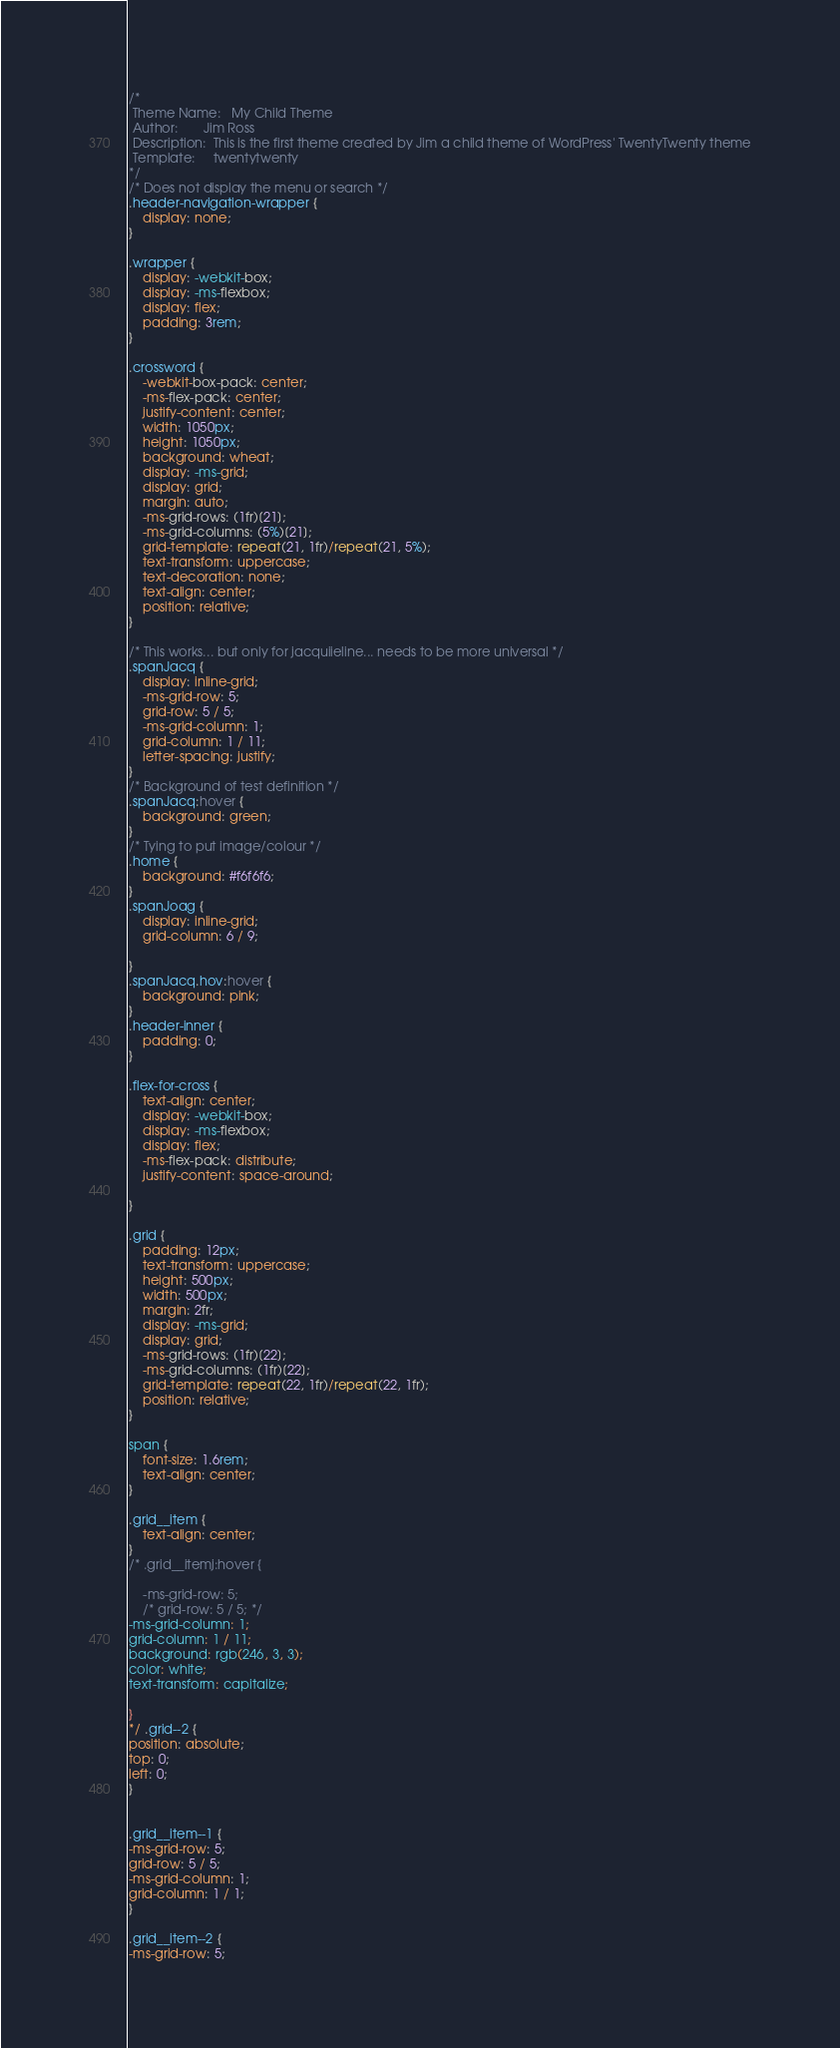Convert code to text. <code><loc_0><loc_0><loc_500><loc_500><_CSS_>/*
 Theme Name:   My Child Theme
 Author:       Jim Ross
 Description:  This is the first theme created by Jim a child theme of WordPress' TwentyTwenty theme
 Template:     twentytwenty
*/
/* Does not display the menu or search */
.header-navigation-wrapper {
    display: none;
}

.wrapper {
    display: -webkit-box;
    display: -ms-flexbox;
    display: flex;
    padding: 3rem;
}

.crossword {
    -webkit-box-pack: center;
    -ms-flex-pack: center;
    justify-content: center;
    width: 1050px;
    height: 1050px;
    background: wheat;
    display: -ms-grid;
    display: grid;
    margin: auto;
    -ms-grid-rows: (1fr)[21];
    -ms-grid-columns: (5%)[21];
    grid-template: repeat(21, 1fr)/repeat(21, 5%);
    text-transform: uppercase;
    text-decoration: none;
    text-align: center;
    position: relative;
}

/* This works... but only for jacquiieline... needs to be more universal */
.spanJacq {
    display: inline-grid;
    -ms-grid-row: 5;
    grid-row: 5 / 5;
    -ms-grid-column: 1;
    grid-column: 1 / 11;
    letter-spacing: justify;
}
/* Background of test definition */
.spanJacq:hover {
    background: green;
}
/* Tying to put image/colour */
.home {
    background: #f6f6f6;
}
.spanJoag {
    display: inline-grid;
    grid-column: 6 / 9;

}
.spanJacq.hov:hover {
    background: pink;
}
.header-inner {
    padding: 0;
}

.flex-for-cross {
    text-align: center;
    display: -webkit-box;
    display: -ms-flexbox;
    display: flex;
    -ms-flex-pack: distribute;
    justify-content: space-around;

}

.grid {
    padding: 12px;
    text-transform: uppercase;
    height: 500px;
    width: 500px;
    margin: 2fr;
    display: -ms-grid;
    display: grid;
    -ms-grid-rows: (1fr)[22];
    -ms-grid-columns: (1fr)[22];
    grid-template: repeat(22, 1fr)/repeat(22, 1fr);
    position: relative;
}

span {
    font-size: 1.6rem;
    text-align: center;
}

.grid__item {
    text-align: center;
}
/* .grid__itemj:hover {

    -ms-grid-row: 5;
    /* grid-row: 5 / 5; */
-ms-grid-column: 1;
grid-column: 1 / 11;
background: rgb(246, 3, 3);
color: white;
text-transform: capitalize;

}
*/ .grid--2 {
position: absolute;
top: 0;
left: 0;
}


.grid__item--1 {
-ms-grid-row: 5;
grid-row: 5 / 5;
-ms-grid-column: 1;
grid-column: 1 / 1;
}

.grid__item--2 {
-ms-grid-row: 5;</code> 